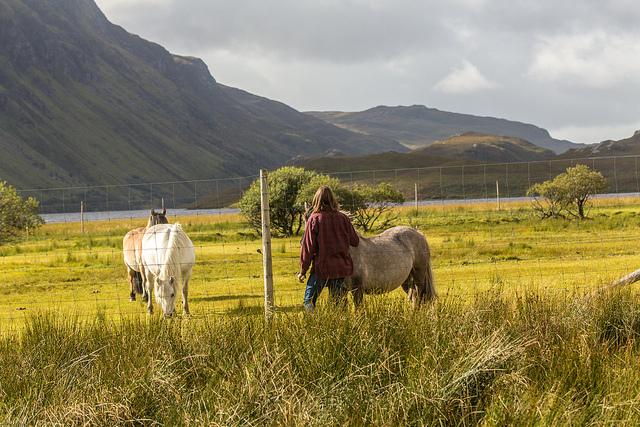Are the animals swimming?
Keep it brief. No. Is it going to rain?
Short answer required. Yes. What gender is the person in the picture?
Be succinct. Female. 